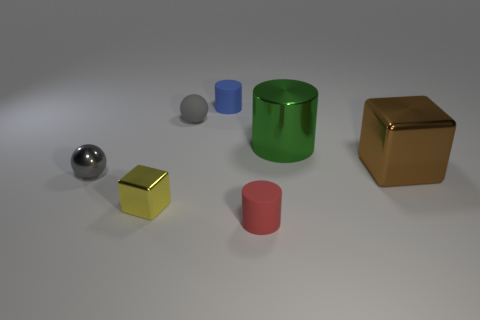Add 2 large purple shiny cylinders. How many objects exist? 9 Subtract all balls. How many objects are left? 5 Add 5 large metal blocks. How many large metal blocks are left? 6 Add 1 gray spheres. How many gray spheres exist? 3 Subtract 0 purple spheres. How many objects are left? 7 Subtract all yellow objects. Subtract all gray shiny balls. How many objects are left? 5 